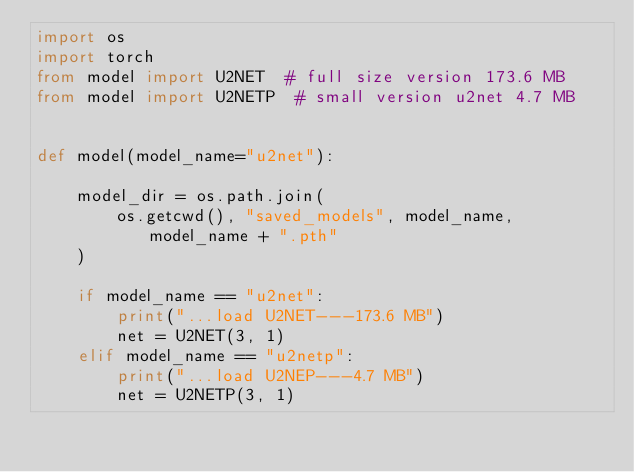<code> <loc_0><loc_0><loc_500><loc_500><_Python_>import os
import torch
from model import U2NET  # full size version 173.6 MB
from model import U2NETP  # small version u2net 4.7 MB


def model(model_name="u2net"):

    model_dir = os.path.join(
        os.getcwd(), "saved_models", model_name, model_name + ".pth"
    )

    if model_name == "u2net":
        print("...load U2NET---173.6 MB")
        net = U2NET(3, 1)
    elif model_name == "u2netp":
        print("...load U2NEP---4.7 MB")
        net = U2NETP(3, 1)</code> 